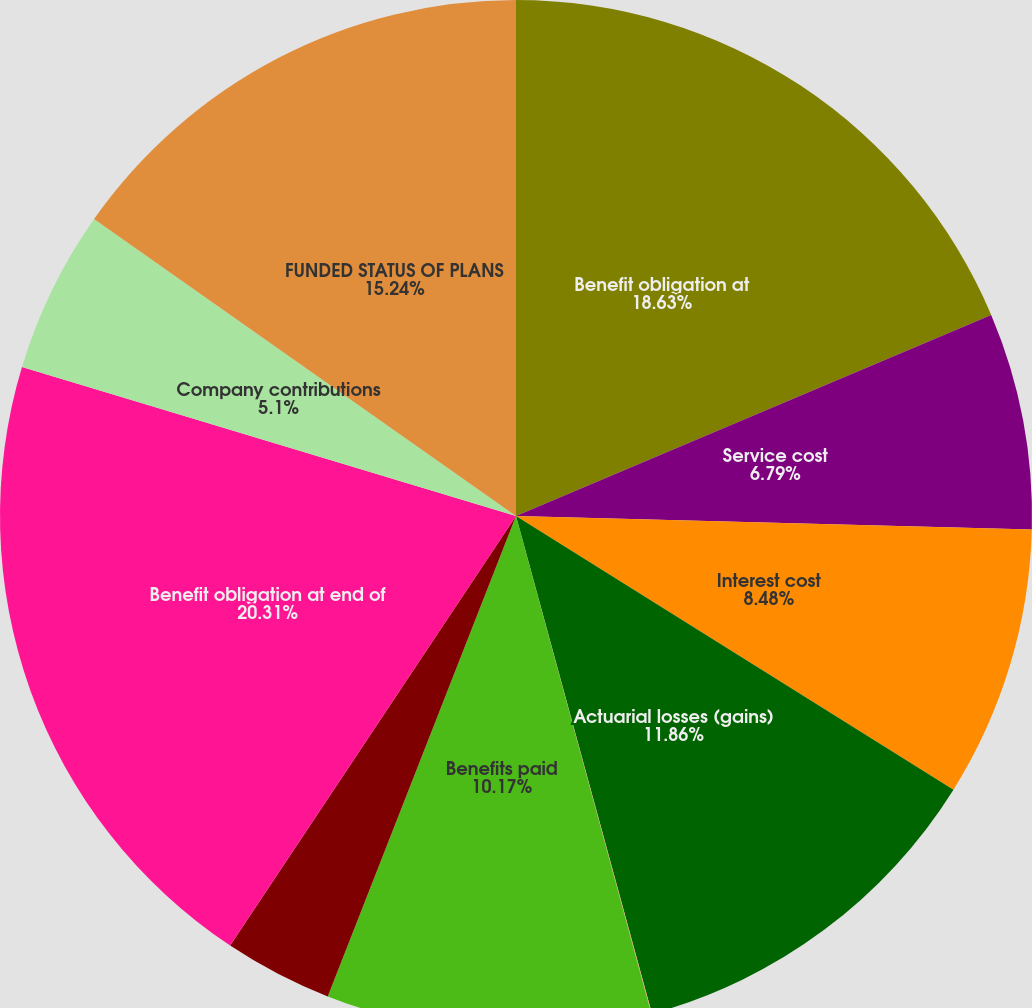<chart> <loc_0><loc_0><loc_500><loc_500><pie_chart><fcel>Benefit obligation at<fcel>Service cost<fcel>Interest cost<fcel>Actuarial losses (gains)<fcel>Plan participant contributions<fcel>Benefits paid<fcel>Currency translation and other<fcel>Benefit obligation at end of<fcel>Company contributions<fcel>FUNDED STATUS OF PLANS<nl><fcel>18.63%<fcel>6.79%<fcel>8.48%<fcel>11.86%<fcel>0.02%<fcel>10.17%<fcel>3.4%<fcel>20.32%<fcel>5.1%<fcel>15.24%<nl></chart> 